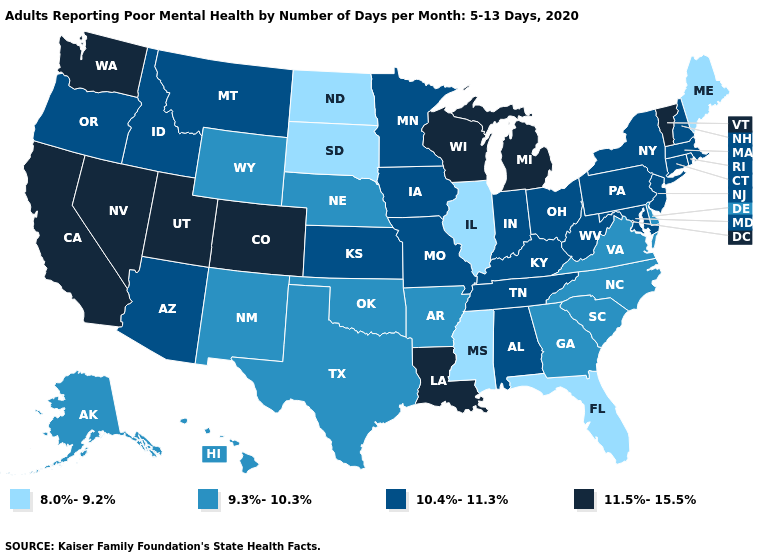How many symbols are there in the legend?
Give a very brief answer. 4. What is the highest value in states that border Tennessee?
Give a very brief answer. 10.4%-11.3%. Which states have the lowest value in the MidWest?
Quick response, please. Illinois, North Dakota, South Dakota. Does Alabama have the same value as Tennessee?
Give a very brief answer. Yes. What is the lowest value in states that border Kansas?
Concise answer only. 9.3%-10.3%. What is the lowest value in the South?
Concise answer only. 8.0%-9.2%. Does Rhode Island have a higher value than Arkansas?
Write a very short answer. Yes. Does Connecticut have the lowest value in the Northeast?
Answer briefly. No. Which states have the lowest value in the West?
Quick response, please. Alaska, Hawaii, New Mexico, Wyoming. What is the value of Kansas?
Be succinct. 10.4%-11.3%. Does Mississippi have the lowest value in the USA?
Quick response, please. Yes. Does South Dakota have the lowest value in the USA?
Answer briefly. Yes. Name the states that have a value in the range 8.0%-9.2%?
Short answer required. Florida, Illinois, Maine, Mississippi, North Dakota, South Dakota. Name the states that have a value in the range 10.4%-11.3%?
Be succinct. Alabama, Arizona, Connecticut, Idaho, Indiana, Iowa, Kansas, Kentucky, Maryland, Massachusetts, Minnesota, Missouri, Montana, New Hampshire, New Jersey, New York, Ohio, Oregon, Pennsylvania, Rhode Island, Tennessee, West Virginia. Among the states that border Vermont , which have the lowest value?
Write a very short answer. Massachusetts, New Hampshire, New York. 